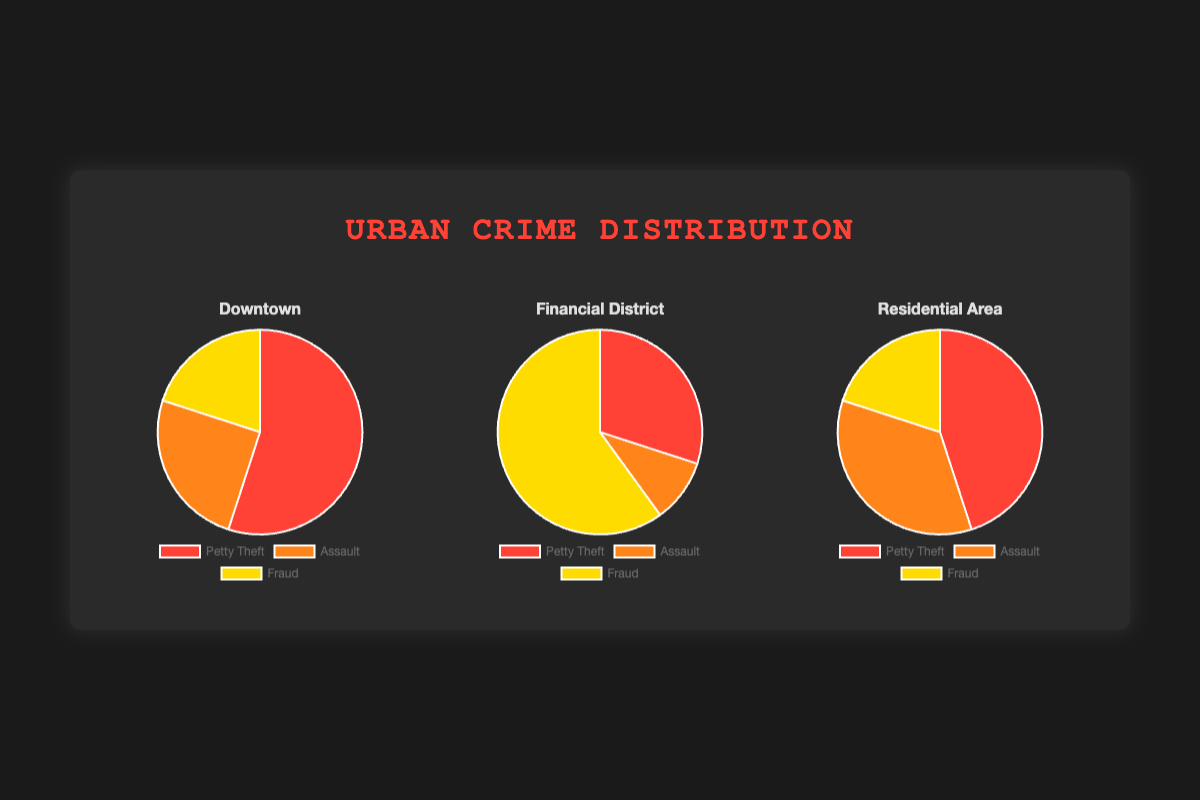What type of crime is most common in the Downtown district? In the Downtown district, Petty Theft has the highest proportion at 55%, which is the largest slice of the pie chart.
Answer: Petty Theft Which district has the highest percentage of Fraud crimes? In the Financial District, Fraud crimes constitute 60%, which is higher than any other district.
Answer: Financial District What is the difference between the percentage of Petty Theft in Downtown and Financial District? The percent of Petty Theft in Downtown is 55%, while in the Financial District it is 30%. The difference is 55% - 30% = 25%.
Answer: 25% Compare the proportion of Assault crimes in the Residential Area and Downtown. Which is higher? In the Residential Area, Assault is 35%, while in Downtown it is 25%. Thus, the Residential Area has a higher proportion of Assault crimes.
Answer: Residential Area What percentage of crimes in the Downtown district are not Fraud-related? In the Downtown district, the percentage of crimes that are not related to Fraud is the sum of Petty Theft (55%) and Assault (25%), which is 55% + 25% = 80%.
Answer: 80% In which district is Petty Theft less common compared to the other two districts? By comparing the percentages of Petty Theft, the Financial District has the lowest at 30% compared to Downtown (55%) and Residential Area (45%).
Answer: Financial District What is the combined percentage of Assault crimes in all three districts? Summing the percentages of Assault crimes in Downtown (25%), Financial District (10%), and Residential Area (35%) gives 25% + 10% + 35% = 70%.
Answer: 70% How does the percentage of total Assualt crimes relate to the total percentage of Petty Theft crimes across the three districts? The total percentage of Assault crimes is 70%, while the total percentage of Petty Theft crimes is 55% + 30% + 45% = 130%. The total percentage of Petty Theft crimes is higher.
Answer: Petty Theft What is the average percentage of Fraud crimes across the three districts? The percentages of Fraud crimes in Downtown, Financial District, and Residential Area are 20%, 60%, and 20% respectively. The average is (20% + 60% + 20%)/3 = 33.33%.
Answer: 33.33% 